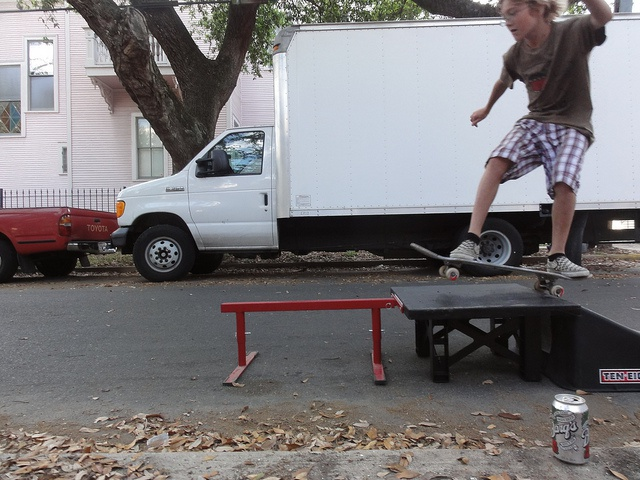Describe the objects in this image and their specific colors. I can see truck in lightgray, black, and darkgray tones, people in lightgray, gray, black, and darkgray tones, truck in lightgray, maroon, black, brown, and gray tones, and skateboard in lightgray, black, gray, and darkgray tones in this image. 